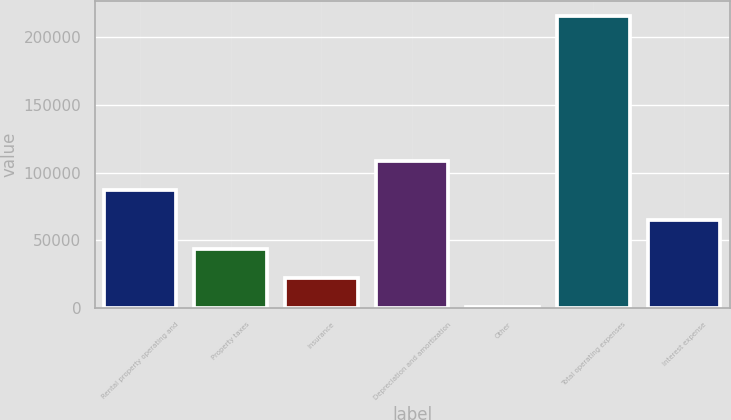<chart> <loc_0><loc_0><loc_500><loc_500><bar_chart><fcel>Rental property operating and<fcel>Property taxes<fcel>Insurance<fcel>Depreciation and amortization<fcel>Other<fcel>Total operating expenses<fcel>Interest expense<nl><fcel>86773.6<fcel>43774.8<fcel>22275.4<fcel>108273<fcel>776<fcel>215770<fcel>65274.2<nl></chart> 